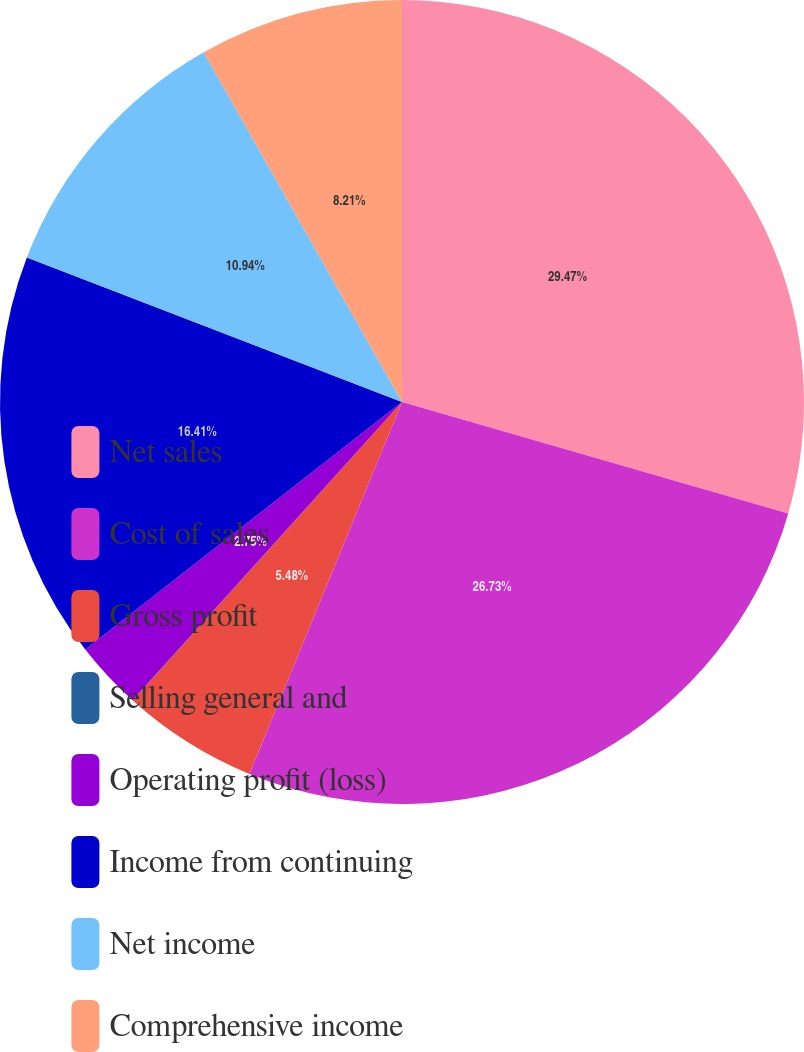Convert chart to OTSL. <chart><loc_0><loc_0><loc_500><loc_500><pie_chart><fcel>Net sales<fcel>Cost of sales<fcel>Gross profit<fcel>Selling general and<fcel>Operating profit (loss)<fcel>Income from continuing<fcel>Net income<fcel>Comprehensive income<nl><fcel>29.47%<fcel>26.73%<fcel>5.48%<fcel>0.01%<fcel>2.75%<fcel>16.41%<fcel>10.94%<fcel>8.21%<nl></chart> 